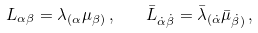<formula> <loc_0><loc_0><loc_500><loc_500>L _ { \alpha \beta } = \lambda _ { ( \alpha } \mu _ { \beta ) } \, , \quad \bar { L } _ { \dot { \alpha } \dot { \beta } } = \bar { \lambda } _ { ( \dot { \alpha } } \bar { \mu } _ { \dot { \beta } ) } \, ,</formula> 